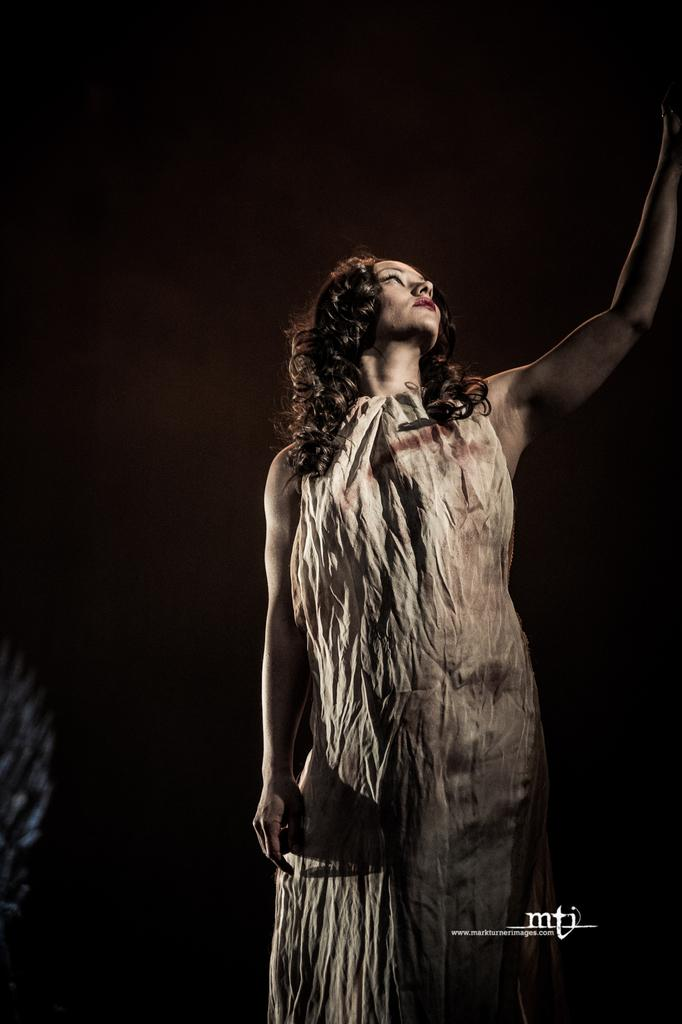What is the main subject of the image? There is a woman standing in the image. Can you describe the background of the image? The background of the image is dark. Is there any text present in the image? Yes, there is text visible on the image. What type of curtain can be seen falling in the image? There is no curtain present in the image, nor is there any indication of something falling. 